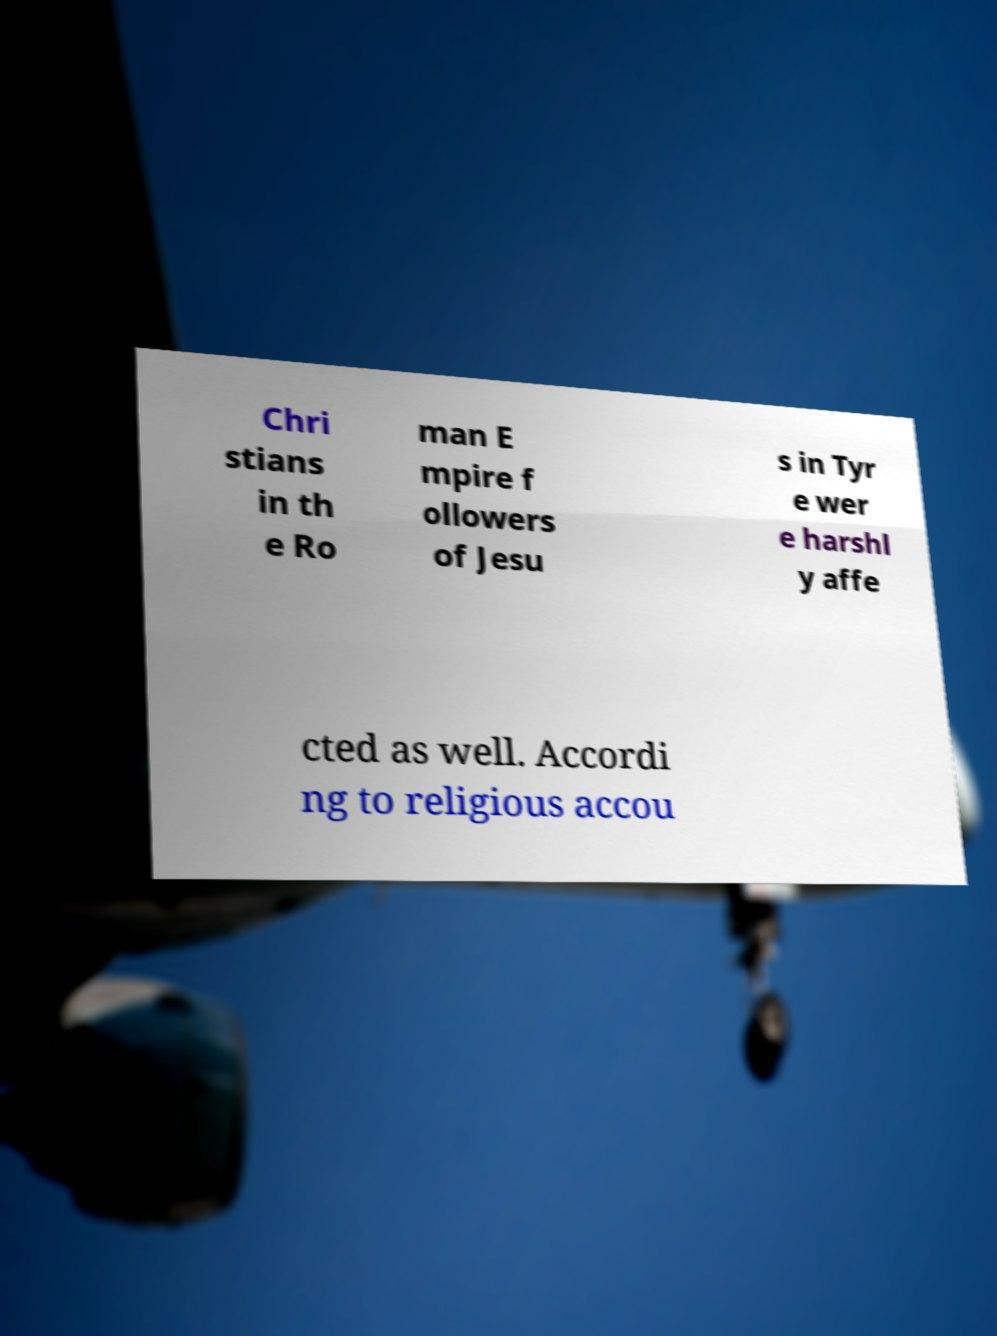I need the written content from this picture converted into text. Can you do that? Chri stians in th e Ro man E mpire f ollowers of Jesu s in Tyr e wer e harshl y affe cted as well. Accordi ng to religious accou 